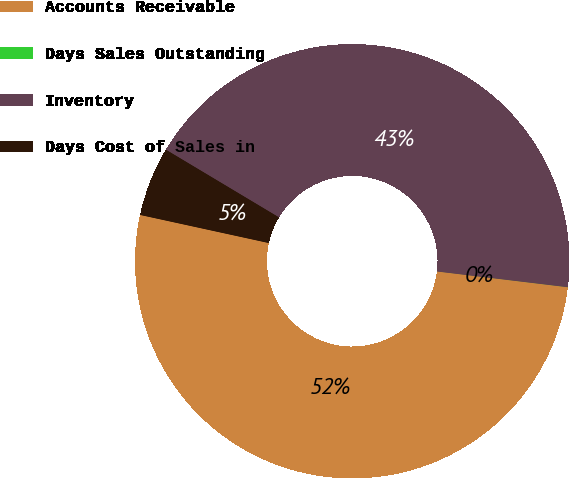Convert chart to OTSL. <chart><loc_0><loc_0><loc_500><loc_500><pie_chart><fcel>Accounts Receivable<fcel>Days Sales Outstanding<fcel>Inventory<fcel>Days Cost of Sales in<nl><fcel>51.51%<fcel>0.01%<fcel>43.32%<fcel>5.16%<nl></chart> 